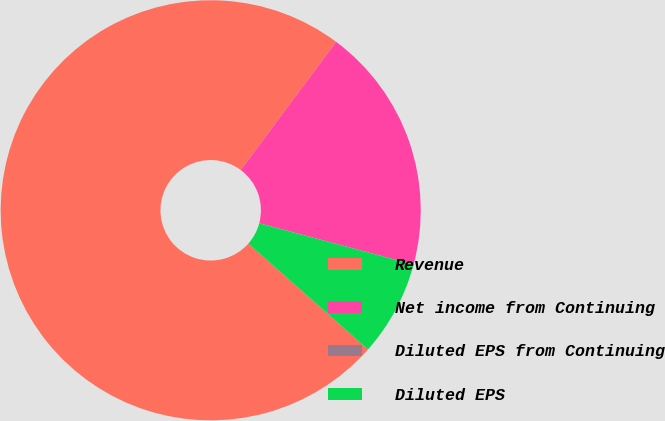Convert chart to OTSL. <chart><loc_0><loc_0><loc_500><loc_500><pie_chart><fcel>Revenue<fcel>Net income from Continuing<fcel>Diluted EPS from Continuing<fcel>Diluted EPS<nl><fcel>73.66%<fcel>18.97%<fcel>0.0%<fcel>7.37%<nl></chart> 